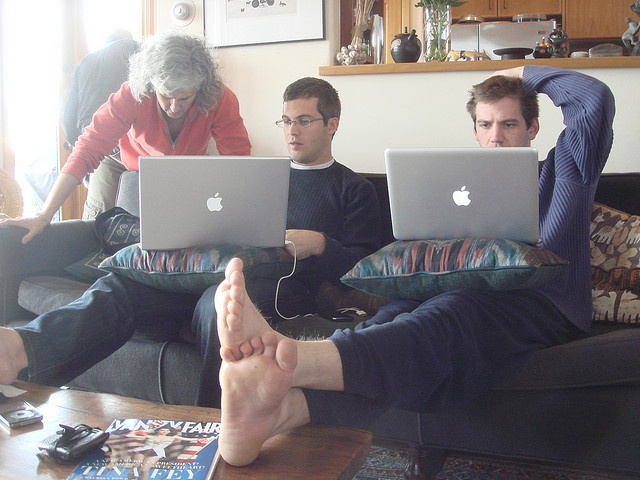Describe the objects in this image and their specific colors. I can see people in white, black, and gray tones, couch in white, gray, and black tones, couch in white and black tones, dining table in white, gray, lightgray, and darkgray tones, and people in white, darkgray, brown, lightgray, and lightpink tones in this image. 